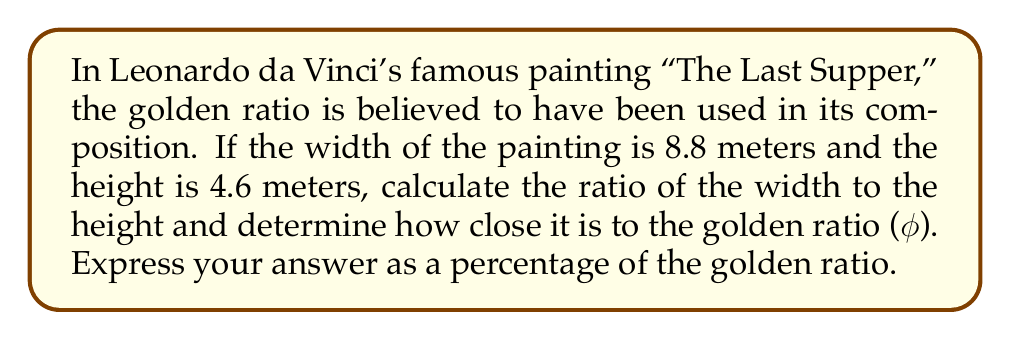Solve this math problem. To solve this problem, we'll follow these steps:

1. Calculate the ratio of the width to the height of the painting.
2. Compare this ratio to the golden ratio.
3. Express the difference as a percentage of the golden ratio.

Step 1: Calculate the ratio of width to height

$$\text{Ratio} = \frac{\text{Width}}{\text{Height}} = \frac{8.8 \text{ m}}{4.6 \text{ m}} \approx 1.9130$$

Step 2: Compare to the golden ratio

The golden ratio (φ) is approximately:

$$\phi = \frac{1 + \sqrt{5}}{2} \approx 1.6180$$

Step 3: Express the difference as a percentage

To calculate how close the painting's ratio is to the golden ratio, we'll use:

$$\text{Percentage} = \frac{\text{Painting's ratio}}{\text{Golden ratio}} \times 100\%$$

$$\text{Percentage} = \frac{1.9130}{1.6180} \times 100\% \approx 118.23\%$$

This means the painting's ratio is about 18.23% larger than the golden ratio.
Answer: The ratio of width to height in "The Last Supper" is approximately 118.23% of the golden ratio. 